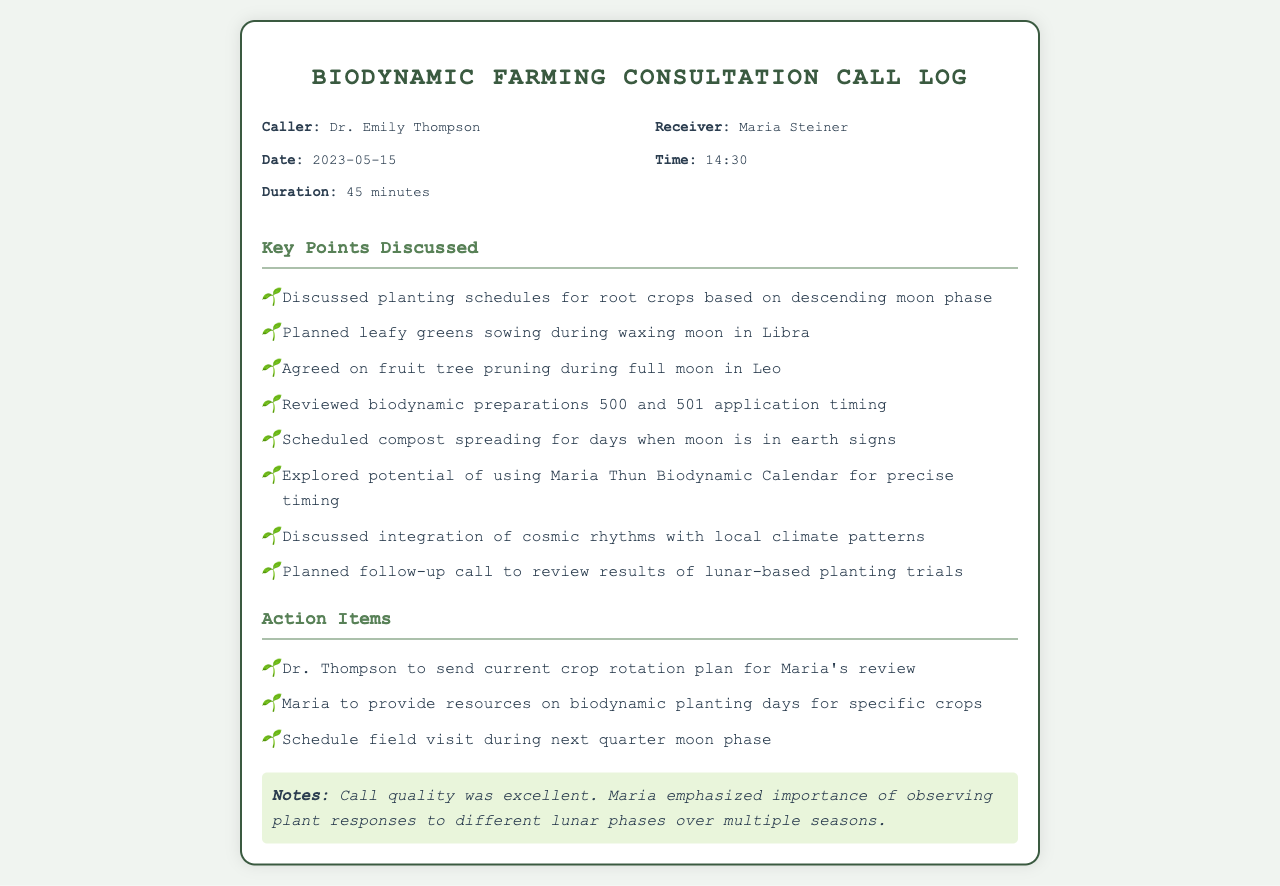What is the date of the call? The date of the call is provided in the call details section of the document.
Answer: 2023-05-15 Who is the receiver of the call? The receiver is identified in the call details section of the document.
Answer: Maria Steiner What was the duration of the call? The duration is listed in the call details section.
Answer: 45 minutes What action item involves reviewing a crop plan? The action items include various tasks discussed during the call.
Answer: Dr. Thompson to send current crop rotation plan Which moon phase is recommended for sowing leafy greens? The planting schedule for leafy greens is mentioned in the key points discussed.
Answer: waxing moon in Libra What was emphasized about plant responses? The notes section highlights an important point made during the call.
Answer: observing plant responses to different lunar phases How many key points were discussed? The number of key points is determined by counting the items listed under the key points discussed section.
Answer: Eight What is one biodynamic preparation mentioned? The key points discussed include specific biodynamic preparations.
Answer: 500 and 501 When is the scheduled field visit? The action items provide information about the timing of the field visit.
Answer: next quarter moon phase 